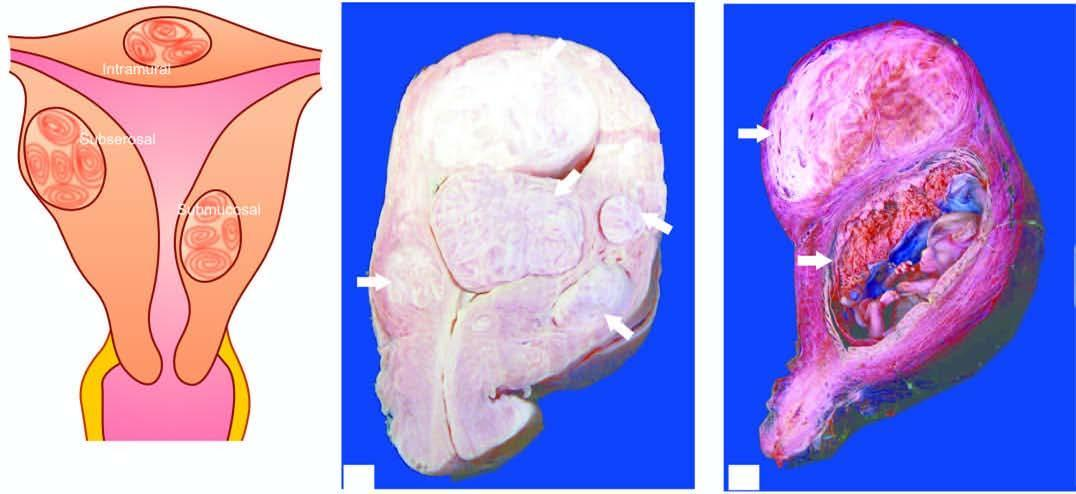does the tumour cells show multiple circumscribed, firm nodular masses of variable sizes-submucosal in location having characteristic whorling?
Answer the question using a single word or phrase. No 